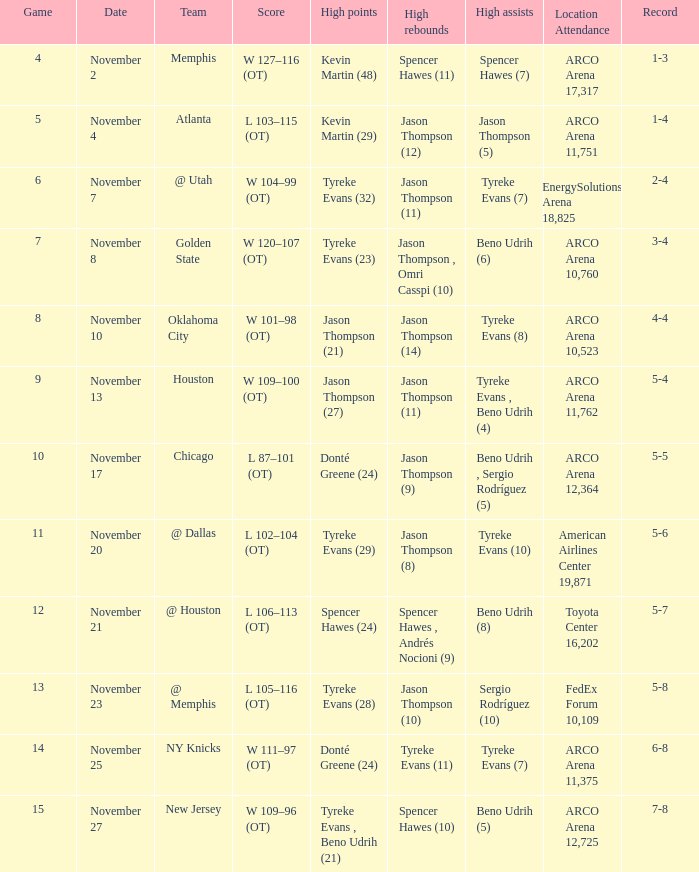If the record is 6-8, what was the score? W 111–97 (OT). 